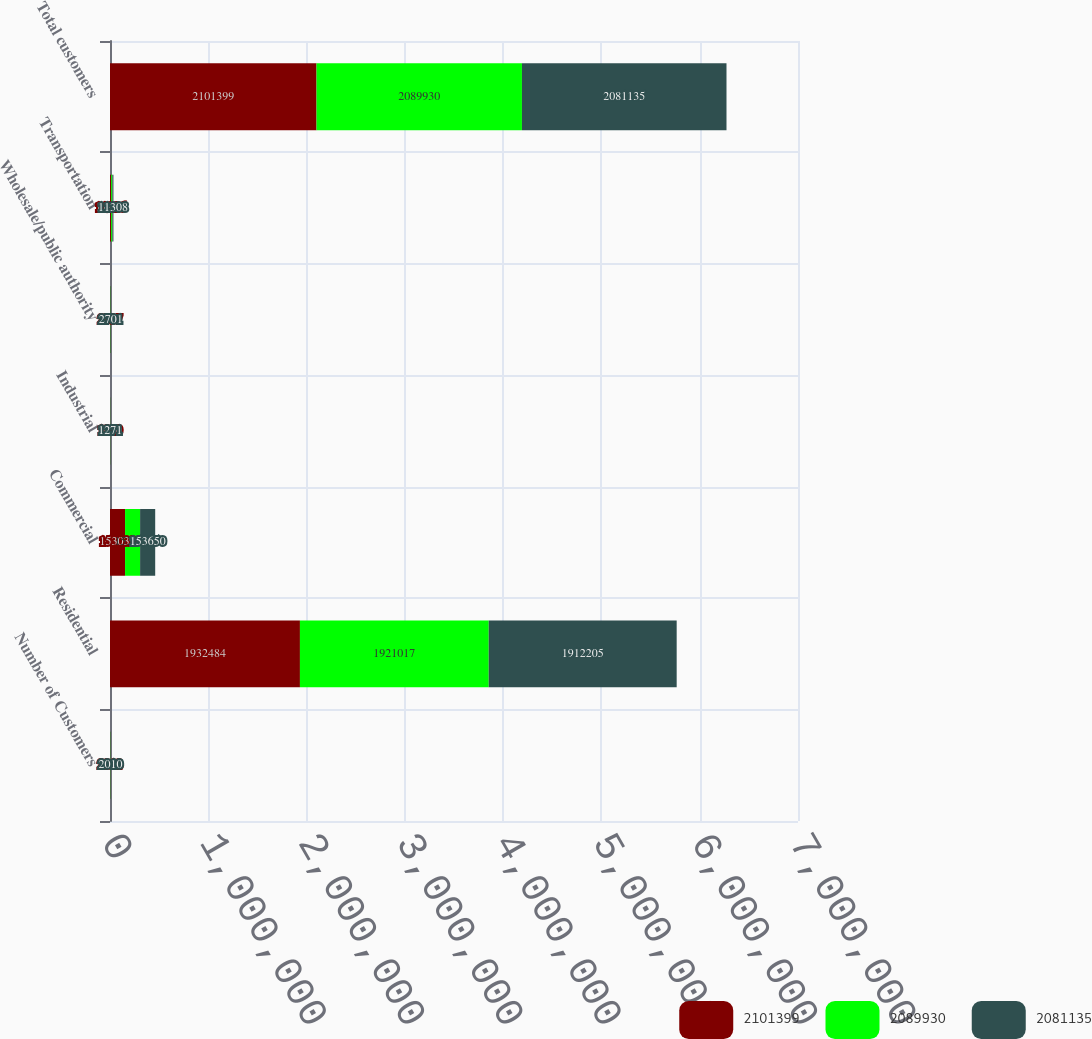Convert chart. <chart><loc_0><loc_0><loc_500><loc_500><stacked_bar_chart><ecel><fcel>Number of Customers<fcel>Residential<fcel>Commercial<fcel>Industrial<fcel>Wholesale/public authority<fcel>Transportation<fcel>Total customers<nl><fcel>2.1014e+06<fcel>2012<fcel>1.93248e+06<fcel>153032<fcel>1220<fcel>2737<fcel>11926<fcel>2.1014e+06<nl><fcel>2.08993e+06<fcel>2011<fcel>1.92102e+06<fcel>153227<fcel>1248<fcel>2730<fcel>11708<fcel>2.08993e+06<nl><fcel>2.08114e+06<fcel>2010<fcel>1.9122e+06<fcel>153650<fcel>1271<fcel>2701<fcel>11308<fcel>2.08114e+06<nl></chart> 